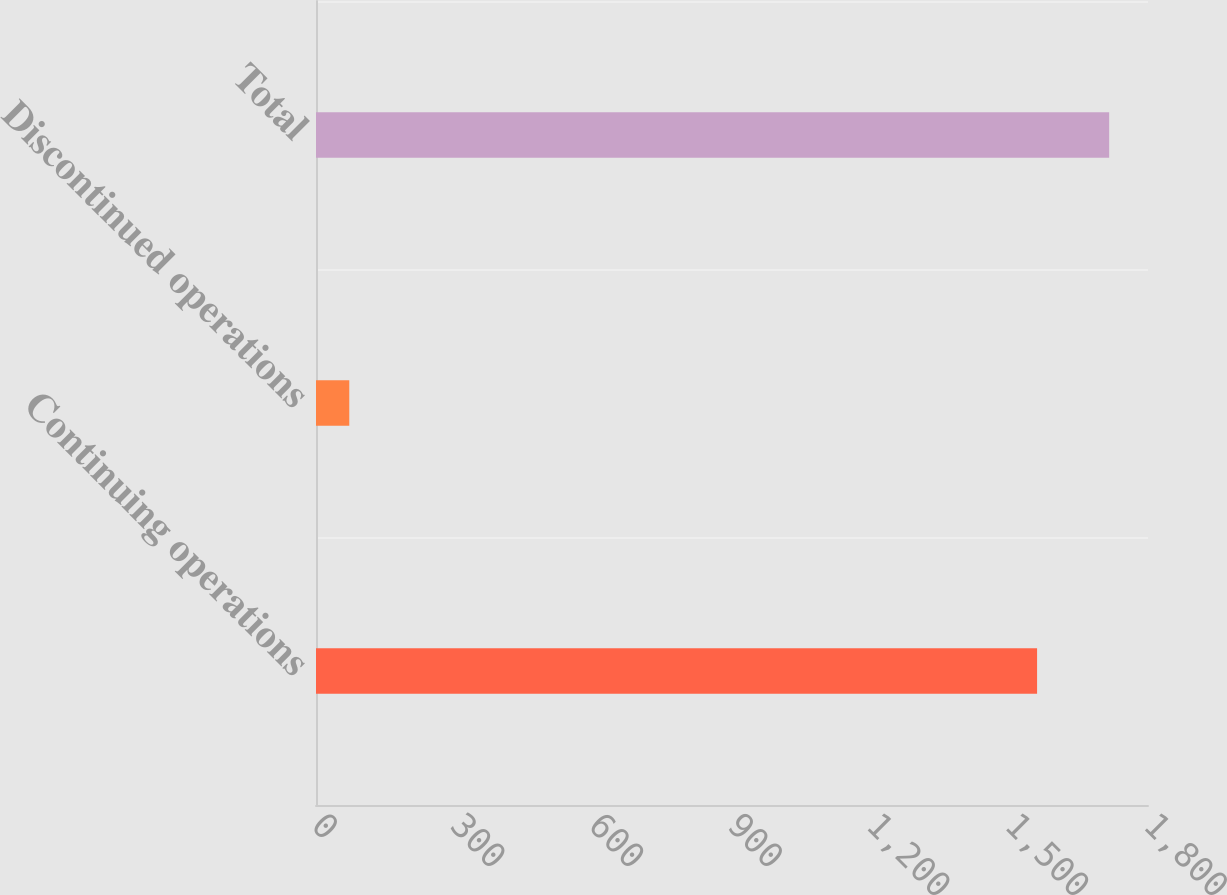<chart> <loc_0><loc_0><loc_500><loc_500><bar_chart><fcel>Continuing operations<fcel>Discontinued operations<fcel>Total<nl><fcel>1560<fcel>72<fcel>1716<nl></chart> 